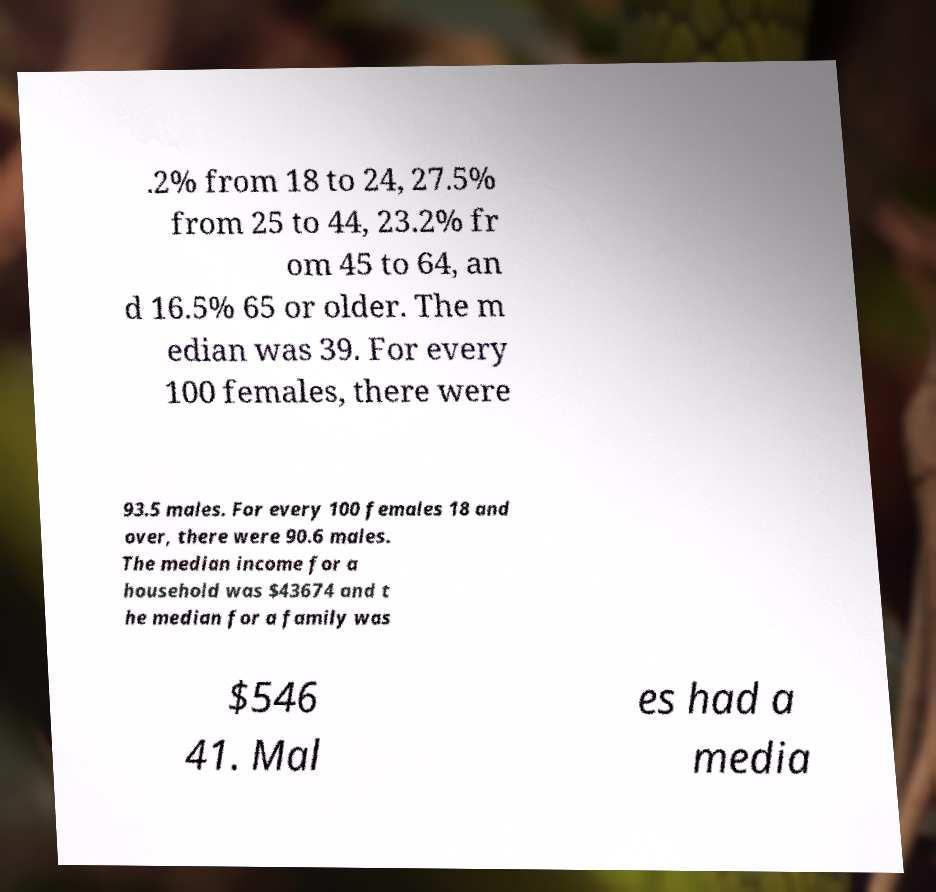Please read and relay the text visible in this image. What does it say? .2% from 18 to 24, 27.5% from 25 to 44, 23.2% fr om 45 to 64, an d 16.5% 65 or older. The m edian was 39. For every 100 females, there were 93.5 males. For every 100 females 18 and over, there were 90.6 males. The median income for a household was $43674 and t he median for a family was $546 41. Mal es had a media 